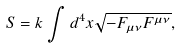<formula> <loc_0><loc_0><loc_500><loc_500>S = k \int { d ^ { 4 } x \sqrt { - F _ { \mu \nu } F ^ { \mu \nu } } } ,</formula> 